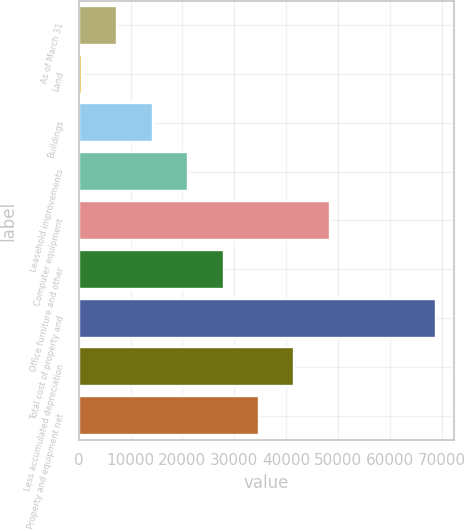<chart> <loc_0><loc_0><loc_500><loc_500><bar_chart><fcel>As of March 31<fcel>Land<fcel>Buildings<fcel>Leasehold improvements<fcel>Computer equipment<fcel>Office furniture and other<fcel>Total cost of property and<fcel>Less accumulated depreciation<fcel>Property and equipment net<nl><fcel>7425.1<fcel>592<fcel>14258.2<fcel>21091.3<fcel>48423.7<fcel>27924.4<fcel>68923<fcel>41590.6<fcel>34757.5<nl></chart> 